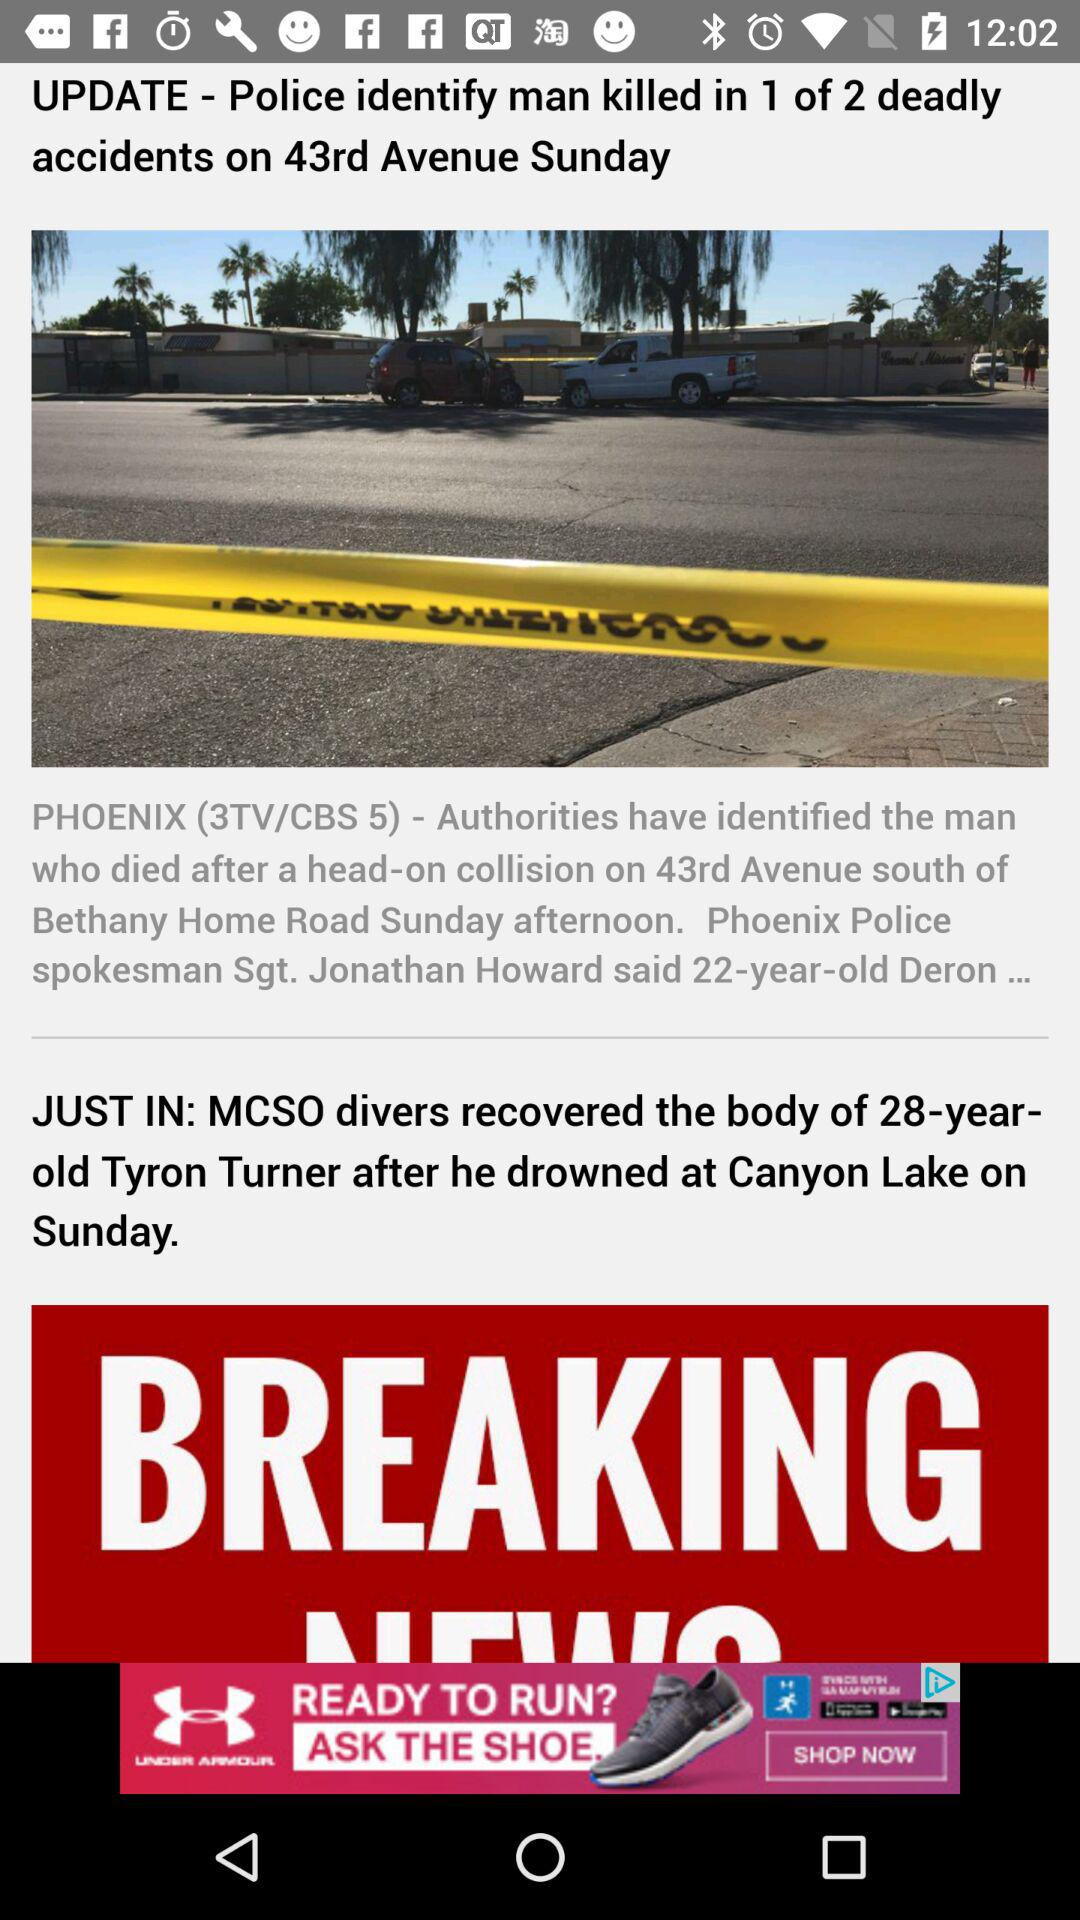Who drowned at Canyon Lake on Sunday? The guy who drowned at Canyon Lake was Tyron Turner. 